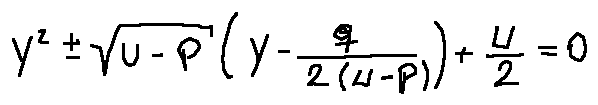Convert formula to latex. <formula><loc_0><loc_0><loc_500><loc_500>y ^ { 2 } \pm \sqrt { u - p } ( y - \frac { q } { 2 ( u - p ) } ) + \frac { u } { 2 } = 0</formula> 